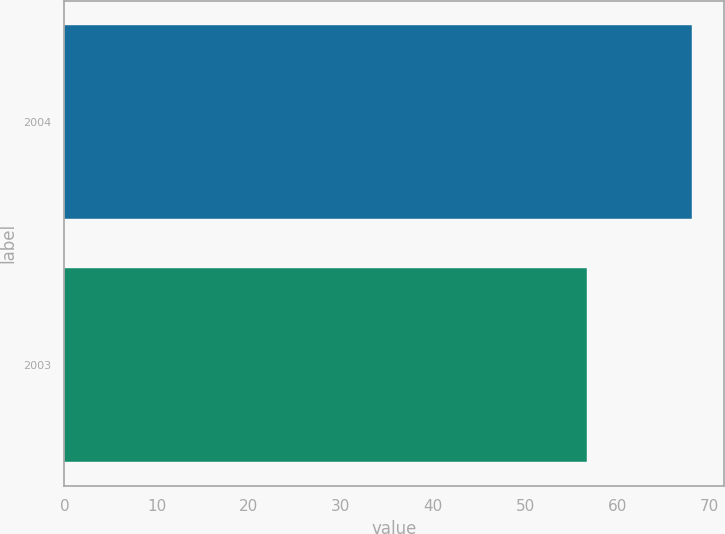Convert chart. <chart><loc_0><loc_0><loc_500><loc_500><bar_chart><fcel>2004<fcel>2003<nl><fcel>68.14<fcel>56.66<nl></chart> 